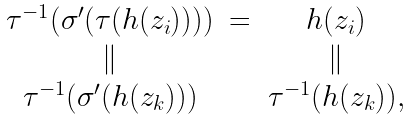<formula> <loc_0><loc_0><loc_500><loc_500>\begin{matrix} \tau ^ { - 1 } ( \sigma ^ { \prime } ( \tau ( h ( z _ { i } ) ) ) ) & = & h ( z _ { i } ) \\ \| & & \| \\ \tau ^ { - 1 } ( \sigma ^ { \prime } ( h ( z _ { k } ) ) ) & & \tau ^ { - 1 } ( h ( z _ { k } ) ) , \end{matrix}</formula> 